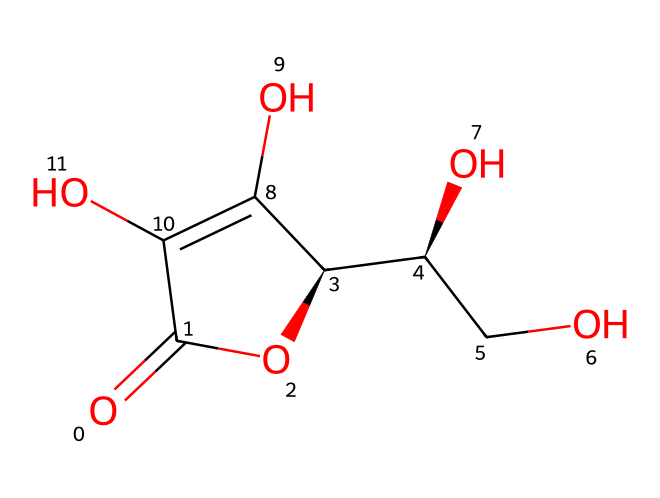What is the IUPAC name of this compound? The SMILES representation indicates the arrangement of atoms in the molecule. By decoding the structure, we identify that it is known as ascorbic acid, which is also known as Vitamin C.
Answer: ascorbic acid How many carbon atoms are present in the chemical structure? Counting the number of carbon atoms represented in the SMILES notation shows there are six carbon atoms in total.
Answer: six What functional groups are present in ascorbic acid? Analyzing the structure, ascorbic acid contains hydroxyl (-OH) groups and a lactone (cyclic ester) group. The presence of these functional groups is critical for its reactivity and biological activity.
Answer: hydroxyl and lactone What kind of acid is ascorbic acid classified as? Based on its structural characteristics and functional groups, ascorbic acid can be classified as a weak organic acid due to its ability to donate protons (H+) in solution.
Answer: weak organic acid How many hydroxyl groups are in the structure? The structure displays three distinct hydroxyl (-OH) functional groups, each contributing to the compound's solubility and interactions in biological systems.
Answer: three What is the role of ascorbic acid in immunity? Ascorbic acid acts as an antioxidant, helping to protect cells from damage by free radicals and enhancing various immune functions, thus playing a vital role in maintaining immune health.
Answer: antioxidant 